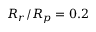Convert formula to latex. <formula><loc_0><loc_0><loc_500><loc_500>R _ { r } / R _ { p } = 0 . 2</formula> 